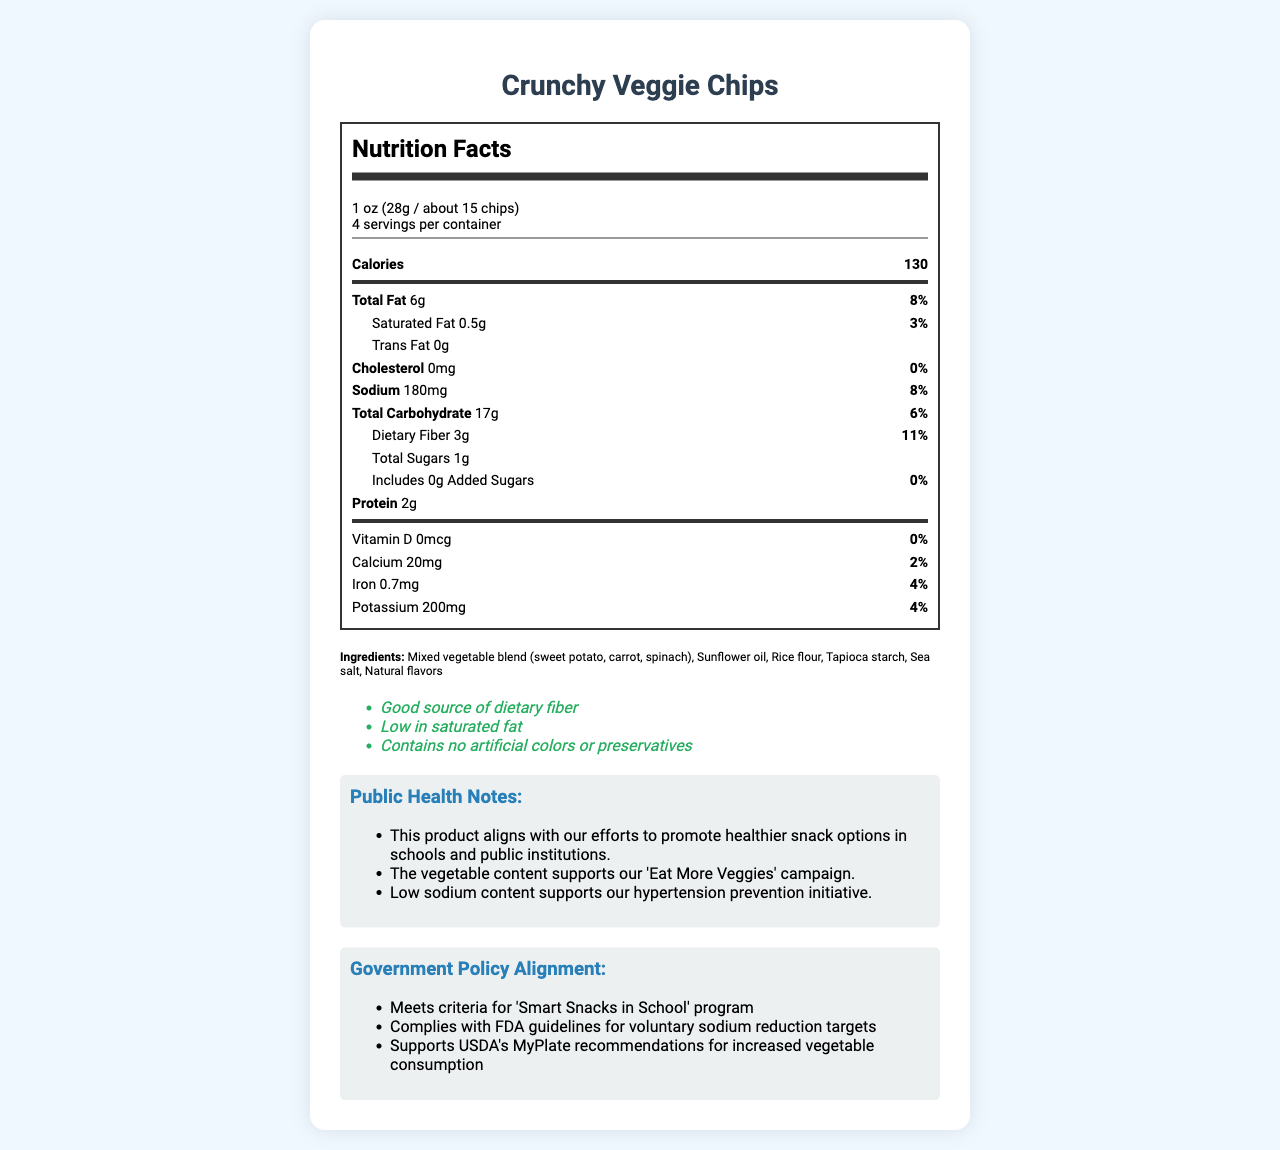What is the serving size for Crunchy Veggie Chips? The serving size information is listed directly below the product name in the document.
Answer: 1 oz (28g / about 15 chips) How many calories are in one serving? The calories per serving are prominently displayed on the Nutrition Facts Label under the bold title "Calories."
Answer: 130 What percentage of the daily value of Total Fat does one serving contain? The percentage of the daily value of Total Fat per serving is listed next to the grams of total fat.
Answer: 8% How many grams of dietary fiber are in one serving? The nutrition label specifies the dietary fiber content under the total carbohydrate section.
Answer: 3 grams Which vitamin or mineral has the highest daily value percentage in one serving? Among the vitamins and minerals listed, dietary fiber has the highest daily value percentage at 11%.
Answer: Dietary Fiber at 11% Does the product contain any trans fat? (Yes/No) The Nutrition Facts Label clearly states that the trans fat content is 0 grams.
Answer: No Which of the following health claims is listed for Crunchy Veggie Chips? A. Contains high levels of iron B. No added sugars C. High protein content D. Good source of calcium The document lists "Contains no artificial colors or preservatives” among the health claims.
Answer: B. No added sugars Which public health initiative does this product support? 1. Obesity prevention program 2. Hypertension prevention initiative 3. Diabetes awareness campaign 4. Heart health program The public health notes section explicitly mentions that low sodium content supports the hypertension prevention initiative.
Answer: 2. Hypertension prevention initiative What is one reason this product aligns with government policies? The government policy alignment section lists meeting criteria for 'Smart Snacks in School' program as one reason.
Answer: Meets criteria for 'Smart Snacks in School' program Does this product contain any artificial colors or preservatives? The health claims section includes "Contains no artificial colors or preservatives."
Answer: No What is the total amount of protein in one serving? The protein content, listed as 2 grams per serving, can be found towards the bottom of the Nutrition Facts Label.
Answer: 2 grams Summarize the main idea of the document. The document outlines all the nutritional components per serving, ingredient list, and health claims of Crunchy Veggie Chips. It emphasizes the product's benefits related to public health goals and its compliance with government guidelines for healthy snacks.
Answer: The document provides detailed nutritional information about Crunchy Veggie Chips, highlighting their serving size, calorie count, and nutrient content. It also specifies ingredients and health claims, and includes public health notes and alignment with government policies, indicating the product's suitability for healthy eating initiatives. List all the ingredients in Crunchy Veggie Chips. The ingredients section of the document lists all the components included in Crunchy Veggie Chips.
Answer: Mixed vegetable blend (sweet potato, carrot, spinach), sunflower oil, rice flour, tapioca starch, sea salt, natural flavors What is the daily value percentage of iron per serving? The daily value percentage for iron is listed under the iron content on the Nutrition Facts Label.
Answer: 4% How many servings are there per container of Crunchy Veggie Chips? The servings per container information is displayed under the serving size detail.
Answer: 4 servings Is there any cholesterol in Crunchy Veggie Chips? The cholesterol content is listed as 0 milligrams with 0% daily value, indicating that there is no cholesterol in the product.
Answer: No How much potassium is in one serving, and what is the corresponding daily value percentage? The potassium content is 200 milligrams, and the daily value percentage for potassium is 4%, both of which are listed on the Nutrition Facts Label.
Answer: 200 milligrams, 4% Is Crunchy Veggie Chips suitable for people allergic to peanuts, tree nuts, soy, or milk products? The document states it is manufactured in a facility that also processes peanuts, tree nuts, soy, and milk products, but does not confirm its suitability for those with allergies.
Answer: Not enough information 